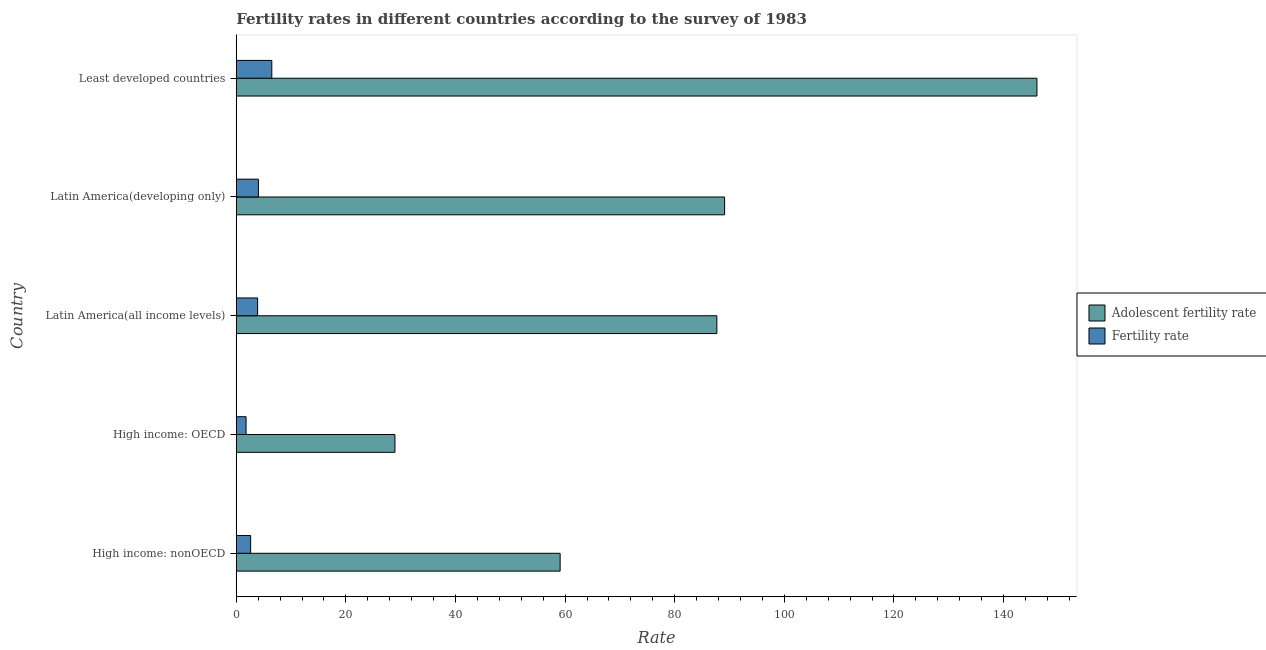Are the number of bars per tick equal to the number of legend labels?
Make the answer very short. Yes. What is the label of the 3rd group of bars from the top?
Offer a very short reply. Latin America(all income levels). What is the fertility rate in Least developed countries?
Provide a succinct answer. 6.49. Across all countries, what is the maximum fertility rate?
Ensure brevity in your answer.  6.49. Across all countries, what is the minimum adolescent fertility rate?
Make the answer very short. 28.95. In which country was the fertility rate maximum?
Ensure brevity in your answer.  Least developed countries. In which country was the fertility rate minimum?
Keep it short and to the point. High income: OECD. What is the total fertility rate in the graph?
Provide a short and direct response. 18.84. What is the difference between the fertility rate in Latin America(developing only) and that in Least developed countries?
Ensure brevity in your answer.  -2.44. What is the difference between the fertility rate in High income: OECD and the adolescent fertility rate in High income: nonOECD?
Make the answer very short. -57.3. What is the average adolescent fertility rate per country?
Your answer should be compact. 82.19. What is the difference between the adolescent fertility rate and fertility rate in High income: nonOECD?
Give a very brief answer. 56.47. In how many countries, is the adolescent fertility rate greater than 124 ?
Provide a short and direct response. 1. What is the ratio of the fertility rate in High income: OECD to that in Latin America(developing only)?
Your answer should be compact. 0.44. What is the difference between the highest and the second highest fertility rate?
Make the answer very short. 2.44. What is the difference between the highest and the lowest adolescent fertility rate?
Offer a very short reply. 117.14. What does the 1st bar from the top in Latin America(all income levels) represents?
Offer a very short reply. Fertility rate. What does the 1st bar from the bottom in Latin America(developing only) represents?
Ensure brevity in your answer.  Adolescent fertility rate. How many bars are there?
Give a very brief answer. 10. How many countries are there in the graph?
Give a very brief answer. 5. Are the values on the major ticks of X-axis written in scientific E-notation?
Provide a succinct answer. No. Where does the legend appear in the graph?
Provide a succinct answer. Center right. How many legend labels are there?
Your answer should be compact. 2. How are the legend labels stacked?
Your answer should be very brief. Vertical. What is the title of the graph?
Ensure brevity in your answer.  Fertility rates in different countries according to the survey of 1983. What is the label or title of the X-axis?
Keep it short and to the point. Rate. What is the label or title of the Y-axis?
Offer a terse response. Country. What is the Rate of Adolescent fertility rate in High income: nonOECD?
Your answer should be compact. 59.09. What is the Rate in Fertility rate in High income: nonOECD?
Offer a very short reply. 2.62. What is the Rate of Adolescent fertility rate in High income: OECD?
Your answer should be very brief. 28.95. What is the Rate in Fertility rate in High income: OECD?
Provide a short and direct response. 1.79. What is the Rate of Adolescent fertility rate in Latin America(all income levels)?
Provide a succinct answer. 87.69. What is the Rate in Fertility rate in Latin America(all income levels)?
Offer a very short reply. 3.9. What is the Rate in Adolescent fertility rate in Latin America(developing only)?
Ensure brevity in your answer.  89.1. What is the Rate of Fertility rate in Latin America(developing only)?
Offer a terse response. 4.04. What is the Rate of Adolescent fertility rate in Least developed countries?
Provide a short and direct response. 146.09. What is the Rate in Fertility rate in Least developed countries?
Keep it short and to the point. 6.49. Across all countries, what is the maximum Rate of Adolescent fertility rate?
Your answer should be very brief. 146.09. Across all countries, what is the maximum Rate in Fertility rate?
Offer a terse response. 6.49. Across all countries, what is the minimum Rate in Adolescent fertility rate?
Ensure brevity in your answer.  28.95. Across all countries, what is the minimum Rate of Fertility rate?
Provide a short and direct response. 1.79. What is the total Rate of Adolescent fertility rate in the graph?
Offer a terse response. 410.93. What is the total Rate of Fertility rate in the graph?
Your response must be concise. 18.84. What is the difference between the Rate of Adolescent fertility rate in High income: nonOECD and that in High income: OECD?
Your answer should be compact. 30.14. What is the difference between the Rate in Fertility rate in High income: nonOECD and that in High income: OECD?
Provide a succinct answer. 0.83. What is the difference between the Rate of Adolescent fertility rate in High income: nonOECD and that in Latin America(all income levels)?
Give a very brief answer. -28.6. What is the difference between the Rate in Fertility rate in High income: nonOECD and that in Latin America(all income levels)?
Offer a very short reply. -1.27. What is the difference between the Rate of Adolescent fertility rate in High income: nonOECD and that in Latin America(developing only)?
Your response must be concise. -30.01. What is the difference between the Rate in Fertility rate in High income: nonOECD and that in Latin America(developing only)?
Your answer should be very brief. -1.42. What is the difference between the Rate in Adolescent fertility rate in High income: nonOECD and that in Least developed countries?
Your response must be concise. -86.99. What is the difference between the Rate of Fertility rate in High income: nonOECD and that in Least developed countries?
Offer a terse response. -3.86. What is the difference between the Rate in Adolescent fertility rate in High income: OECD and that in Latin America(all income levels)?
Your response must be concise. -58.74. What is the difference between the Rate in Fertility rate in High income: OECD and that in Latin America(all income levels)?
Your response must be concise. -2.11. What is the difference between the Rate in Adolescent fertility rate in High income: OECD and that in Latin America(developing only)?
Make the answer very short. -60.15. What is the difference between the Rate in Fertility rate in High income: OECD and that in Latin America(developing only)?
Your answer should be very brief. -2.25. What is the difference between the Rate of Adolescent fertility rate in High income: OECD and that in Least developed countries?
Provide a short and direct response. -117.14. What is the difference between the Rate in Fertility rate in High income: OECD and that in Least developed countries?
Your response must be concise. -4.7. What is the difference between the Rate in Adolescent fertility rate in Latin America(all income levels) and that in Latin America(developing only)?
Your response must be concise. -1.41. What is the difference between the Rate in Fertility rate in Latin America(all income levels) and that in Latin America(developing only)?
Provide a short and direct response. -0.15. What is the difference between the Rate in Adolescent fertility rate in Latin America(all income levels) and that in Least developed countries?
Your answer should be compact. -58.4. What is the difference between the Rate of Fertility rate in Latin America(all income levels) and that in Least developed countries?
Offer a terse response. -2.59. What is the difference between the Rate in Adolescent fertility rate in Latin America(developing only) and that in Least developed countries?
Provide a short and direct response. -56.99. What is the difference between the Rate in Fertility rate in Latin America(developing only) and that in Least developed countries?
Provide a short and direct response. -2.44. What is the difference between the Rate of Adolescent fertility rate in High income: nonOECD and the Rate of Fertility rate in High income: OECD?
Your answer should be very brief. 57.3. What is the difference between the Rate in Adolescent fertility rate in High income: nonOECD and the Rate in Fertility rate in Latin America(all income levels)?
Ensure brevity in your answer.  55.2. What is the difference between the Rate in Adolescent fertility rate in High income: nonOECD and the Rate in Fertility rate in Latin America(developing only)?
Offer a very short reply. 55.05. What is the difference between the Rate of Adolescent fertility rate in High income: nonOECD and the Rate of Fertility rate in Least developed countries?
Offer a terse response. 52.61. What is the difference between the Rate in Adolescent fertility rate in High income: OECD and the Rate in Fertility rate in Latin America(all income levels)?
Offer a very short reply. 25.06. What is the difference between the Rate of Adolescent fertility rate in High income: OECD and the Rate of Fertility rate in Latin America(developing only)?
Offer a very short reply. 24.91. What is the difference between the Rate of Adolescent fertility rate in High income: OECD and the Rate of Fertility rate in Least developed countries?
Offer a terse response. 22.47. What is the difference between the Rate of Adolescent fertility rate in Latin America(all income levels) and the Rate of Fertility rate in Latin America(developing only)?
Keep it short and to the point. 83.65. What is the difference between the Rate in Adolescent fertility rate in Latin America(all income levels) and the Rate in Fertility rate in Least developed countries?
Give a very brief answer. 81.21. What is the difference between the Rate of Adolescent fertility rate in Latin America(developing only) and the Rate of Fertility rate in Least developed countries?
Provide a succinct answer. 82.61. What is the average Rate of Adolescent fertility rate per country?
Offer a terse response. 82.19. What is the average Rate of Fertility rate per country?
Give a very brief answer. 3.77. What is the difference between the Rate of Adolescent fertility rate and Rate of Fertility rate in High income: nonOECD?
Your response must be concise. 56.47. What is the difference between the Rate in Adolescent fertility rate and Rate in Fertility rate in High income: OECD?
Give a very brief answer. 27.16. What is the difference between the Rate in Adolescent fertility rate and Rate in Fertility rate in Latin America(all income levels)?
Ensure brevity in your answer.  83.8. What is the difference between the Rate in Adolescent fertility rate and Rate in Fertility rate in Latin America(developing only)?
Your answer should be very brief. 85.06. What is the difference between the Rate in Adolescent fertility rate and Rate in Fertility rate in Least developed countries?
Ensure brevity in your answer.  139.6. What is the ratio of the Rate in Adolescent fertility rate in High income: nonOECD to that in High income: OECD?
Provide a succinct answer. 2.04. What is the ratio of the Rate in Fertility rate in High income: nonOECD to that in High income: OECD?
Keep it short and to the point. 1.47. What is the ratio of the Rate of Adolescent fertility rate in High income: nonOECD to that in Latin America(all income levels)?
Your response must be concise. 0.67. What is the ratio of the Rate in Fertility rate in High income: nonOECD to that in Latin America(all income levels)?
Your answer should be very brief. 0.67. What is the ratio of the Rate of Adolescent fertility rate in High income: nonOECD to that in Latin America(developing only)?
Keep it short and to the point. 0.66. What is the ratio of the Rate in Fertility rate in High income: nonOECD to that in Latin America(developing only)?
Your answer should be very brief. 0.65. What is the ratio of the Rate in Adolescent fertility rate in High income: nonOECD to that in Least developed countries?
Your answer should be very brief. 0.4. What is the ratio of the Rate in Fertility rate in High income: nonOECD to that in Least developed countries?
Your answer should be very brief. 0.4. What is the ratio of the Rate of Adolescent fertility rate in High income: OECD to that in Latin America(all income levels)?
Offer a terse response. 0.33. What is the ratio of the Rate of Fertility rate in High income: OECD to that in Latin America(all income levels)?
Offer a terse response. 0.46. What is the ratio of the Rate in Adolescent fertility rate in High income: OECD to that in Latin America(developing only)?
Your answer should be compact. 0.33. What is the ratio of the Rate of Fertility rate in High income: OECD to that in Latin America(developing only)?
Offer a terse response. 0.44. What is the ratio of the Rate in Adolescent fertility rate in High income: OECD to that in Least developed countries?
Give a very brief answer. 0.2. What is the ratio of the Rate of Fertility rate in High income: OECD to that in Least developed countries?
Offer a terse response. 0.28. What is the ratio of the Rate in Adolescent fertility rate in Latin America(all income levels) to that in Latin America(developing only)?
Make the answer very short. 0.98. What is the ratio of the Rate in Fertility rate in Latin America(all income levels) to that in Latin America(developing only)?
Your response must be concise. 0.96. What is the ratio of the Rate in Adolescent fertility rate in Latin America(all income levels) to that in Least developed countries?
Your answer should be very brief. 0.6. What is the ratio of the Rate of Fertility rate in Latin America(all income levels) to that in Least developed countries?
Your response must be concise. 0.6. What is the ratio of the Rate of Adolescent fertility rate in Latin America(developing only) to that in Least developed countries?
Keep it short and to the point. 0.61. What is the ratio of the Rate of Fertility rate in Latin America(developing only) to that in Least developed countries?
Your response must be concise. 0.62. What is the difference between the highest and the second highest Rate in Adolescent fertility rate?
Keep it short and to the point. 56.99. What is the difference between the highest and the second highest Rate of Fertility rate?
Provide a succinct answer. 2.44. What is the difference between the highest and the lowest Rate in Adolescent fertility rate?
Your answer should be very brief. 117.14. What is the difference between the highest and the lowest Rate of Fertility rate?
Your answer should be compact. 4.7. 